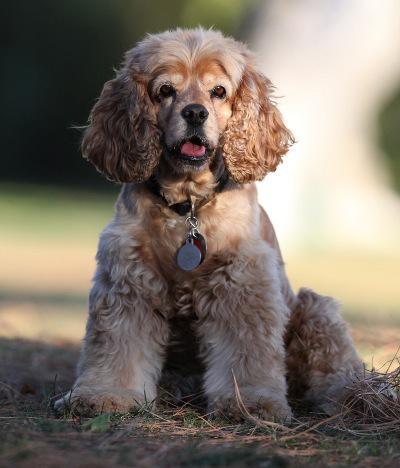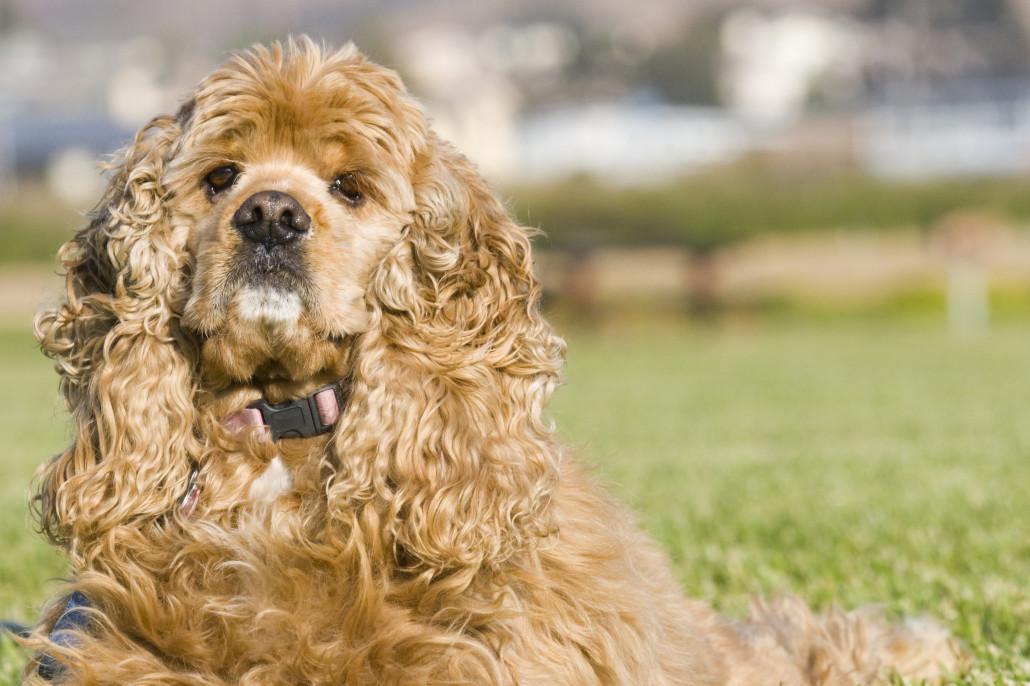The first image is the image on the left, the second image is the image on the right. For the images shown, is this caption "The dog in the right image is lying down on the ground." true? Answer yes or no. Yes. The first image is the image on the left, the second image is the image on the right. Evaluate the accuracy of this statement regarding the images: "In the left image, there's a dog running through the grass while carrying something in its mouth.". Is it true? Answer yes or no. No. 